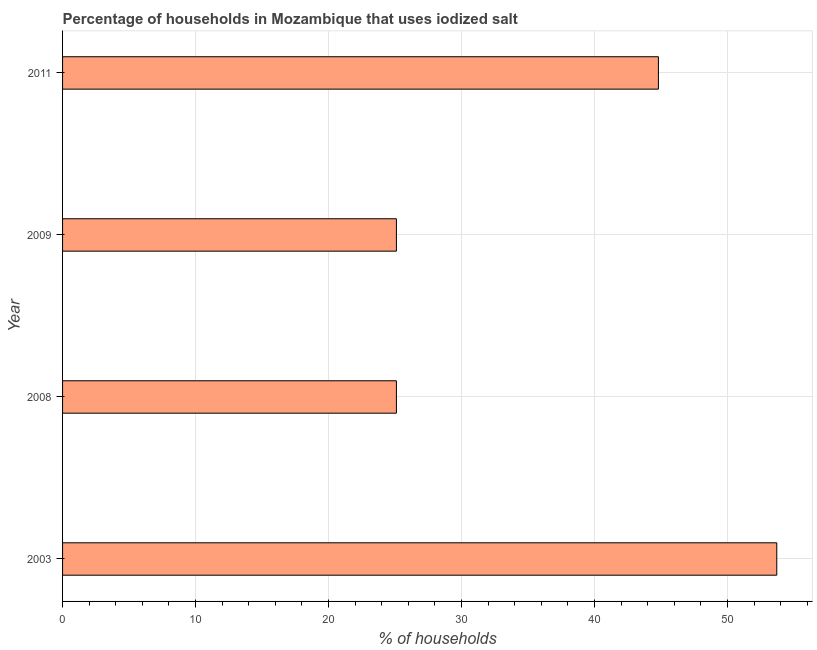Does the graph contain grids?
Ensure brevity in your answer.  Yes. What is the title of the graph?
Ensure brevity in your answer.  Percentage of households in Mozambique that uses iodized salt. What is the label or title of the X-axis?
Offer a terse response. % of households. What is the percentage of households where iodized salt is consumed in 2011?
Your answer should be compact. 44.8. Across all years, what is the maximum percentage of households where iodized salt is consumed?
Offer a very short reply. 53.7. Across all years, what is the minimum percentage of households where iodized salt is consumed?
Give a very brief answer. 25.1. In which year was the percentage of households where iodized salt is consumed maximum?
Offer a terse response. 2003. In which year was the percentage of households where iodized salt is consumed minimum?
Provide a short and direct response. 2008. What is the sum of the percentage of households where iodized salt is consumed?
Your answer should be very brief. 148.7. What is the difference between the percentage of households where iodized salt is consumed in 2003 and 2009?
Ensure brevity in your answer.  28.6. What is the average percentage of households where iodized salt is consumed per year?
Keep it short and to the point. 37.17. What is the median percentage of households where iodized salt is consumed?
Your answer should be compact. 34.95. In how many years, is the percentage of households where iodized salt is consumed greater than 10 %?
Offer a very short reply. 4. Do a majority of the years between 2003 and 2009 (inclusive) have percentage of households where iodized salt is consumed greater than 36 %?
Provide a short and direct response. No. What is the ratio of the percentage of households where iodized salt is consumed in 2003 to that in 2011?
Give a very brief answer. 1.2. Is the difference between the percentage of households where iodized salt is consumed in 2003 and 2011 greater than the difference between any two years?
Ensure brevity in your answer.  No. Is the sum of the percentage of households where iodized salt is consumed in 2008 and 2009 greater than the maximum percentage of households where iodized salt is consumed across all years?
Your answer should be compact. No. What is the difference between the highest and the lowest percentage of households where iodized salt is consumed?
Your response must be concise. 28.6. How many bars are there?
Ensure brevity in your answer.  4. How many years are there in the graph?
Make the answer very short. 4. What is the % of households of 2003?
Offer a very short reply. 53.7. What is the % of households of 2008?
Make the answer very short. 25.1. What is the % of households of 2009?
Give a very brief answer. 25.1. What is the % of households in 2011?
Offer a terse response. 44.8. What is the difference between the % of households in 2003 and 2008?
Provide a succinct answer. 28.6. What is the difference between the % of households in 2003 and 2009?
Provide a short and direct response. 28.6. What is the difference between the % of households in 2008 and 2009?
Make the answer very short. 0. What is the difference between the % of households in 2008 and 2011?
Your answer should be compact. -19.7. What is the difference between the % of households in 2009 and 2011?
Your response must be concise. -19.7. What is the ratio of the % of households in 2003 to that in 2008?
Your response must be concise. 2.14. What is the ratio of the % of households in 2003 to that in 2009?
Make the answer very short. 2.14. What is the ratio of the % of households in 2003 to that in 2011?
Your answer should be compact. 1.2. What is the ratio of the % of households in 2008 to that in 2011?
Make the answer very short. 0.56. What is the ratio of the % of households in 2009 to that in 2011?
Keep it short and to the point. 0.56. 